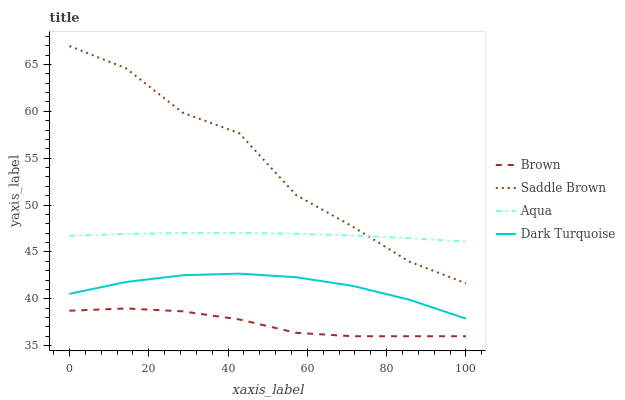Does Brown have the minimum area under the curve?
Answer yes or no. Yes. Does Saddle Brown have the maximum area under the curve?
Answer yes or no. Yes. Does Aqua have the minimum area under the curve?
Answer yes or no. No. Does Aqua have the maximum area under the curve?
Answer yes or no. No. Is Aqua the smoothest?
Answer yes or no. Yes. Is Saddle Brown the roughest?
Answer yes or no. Yes. Is Saddle Brown the smoothest?
Answer yes or no. No. Is Aqua the roughest?
Answer yes or no. No. Does Brown have the lowest value?
Answer yes or no. Yes. Does Saddle Brown have the lowest value?
Answer yes or no. No. Does Saddle Brown have the highest value?
Answer yes or no. Yes. Does Aqua have the highest value?
Answer yes or no. No. Is Dark Turquoise less than Aqua?
Answer yes or no. Yes. Is Saddle Brown greater than Dark Turquoise?
Answer yes or no. Yes. Does Aqua intersect Saddle Brown?
Answer yes or no. Yes. Is Aqua less than Saddle Brown?
Answer yes or no. No. Is Aqua greater than Saddle Brown?
Answer yes or no. No. Does Dark Turquoise intersect Aqua?
Answer yes or no. No. 